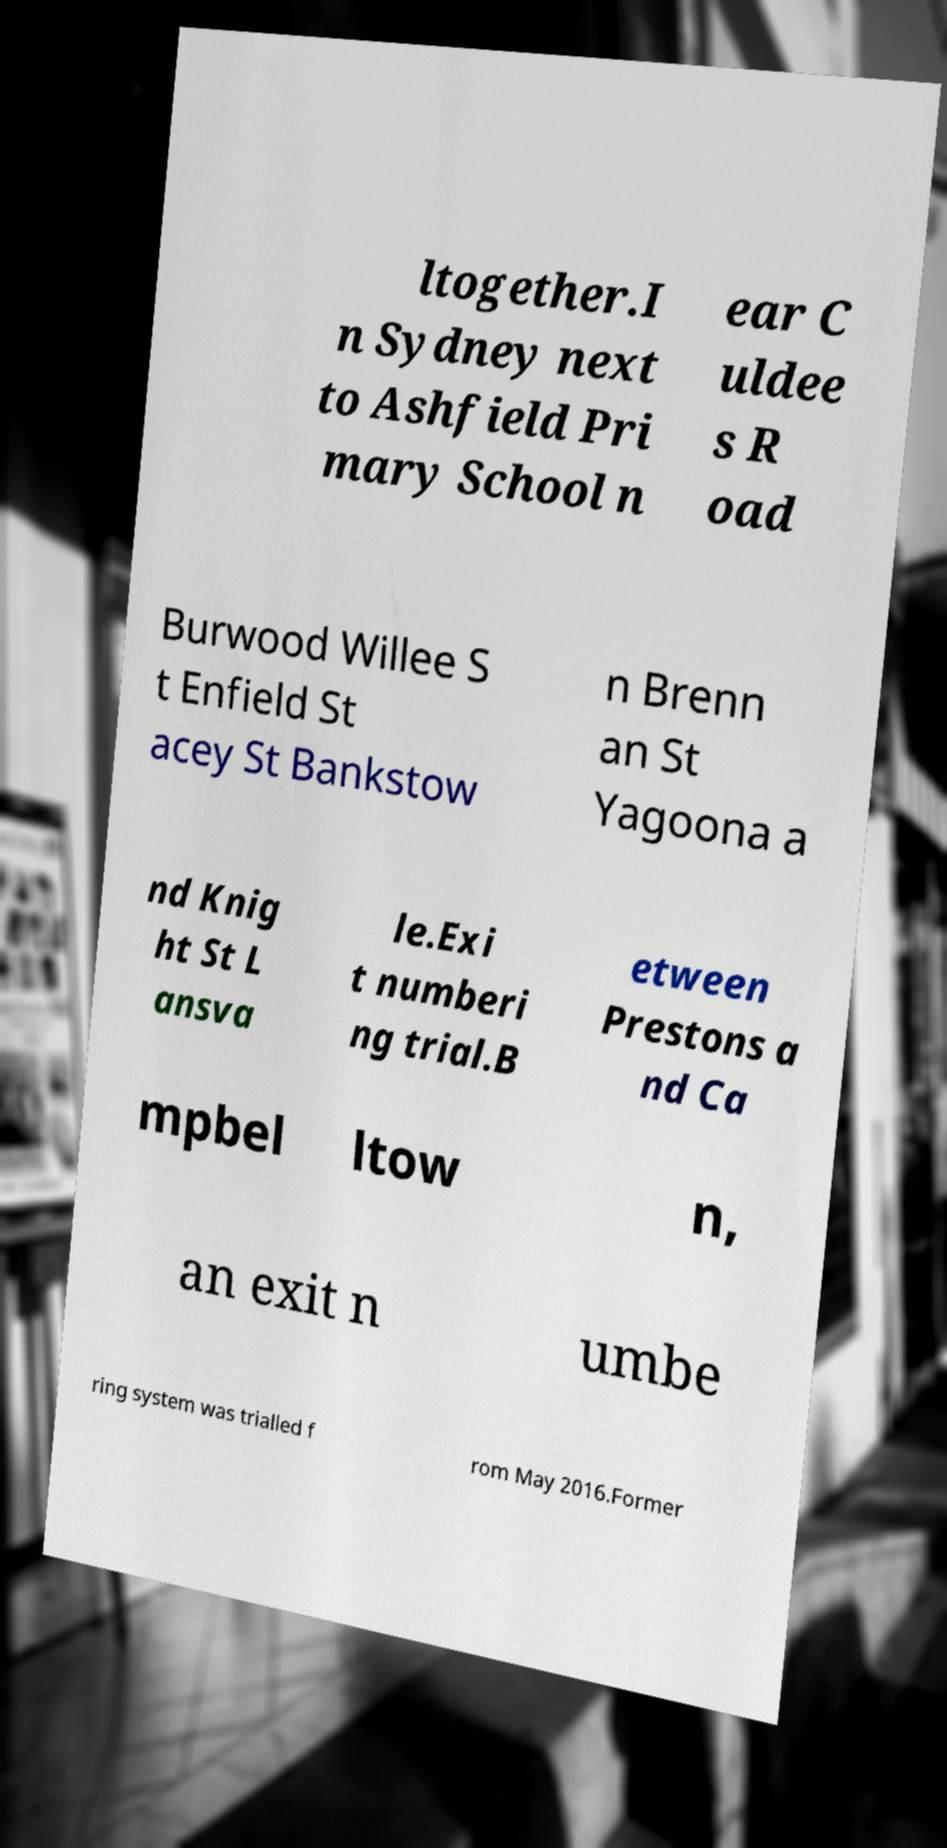There's text embedded in this image that I need extracted. Can you transcribe it verbatim? ltogether.I n Sydney next to Ashfield Pri mary School n ear C uldee s R oad Burwood Willee S t Enfield St acey St Bankstow n Brenn an St Yagoona a nd Knig ht St L ansva le.Exi t numberi ng trial.B etween Prestons a nd Ca mpbel ltow n, an exit n umbe ring system was trialled f rom May 2016.Former 